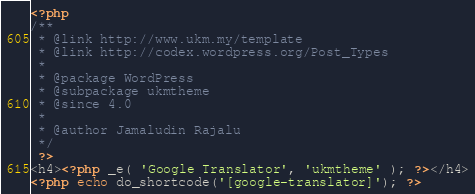<code> <loc_0><loc_0><loc_500><loc_500><_PHP_><?php
/**
 * @link http://www.ukm.my/template
 * @link http://codex.wordpress.org/Post_Types
 *
 * @package WordPress
 * @subpackage ukmtheme
 * @since 4.0
 *
 * @author Jamaludin Rajalu
 */
 ?>
<h4><?php _e( 'Google Translator', 'ukmtheme' ); ?></h4>
<?php echo do_shortcode('[google-translator]'); ?></code> 